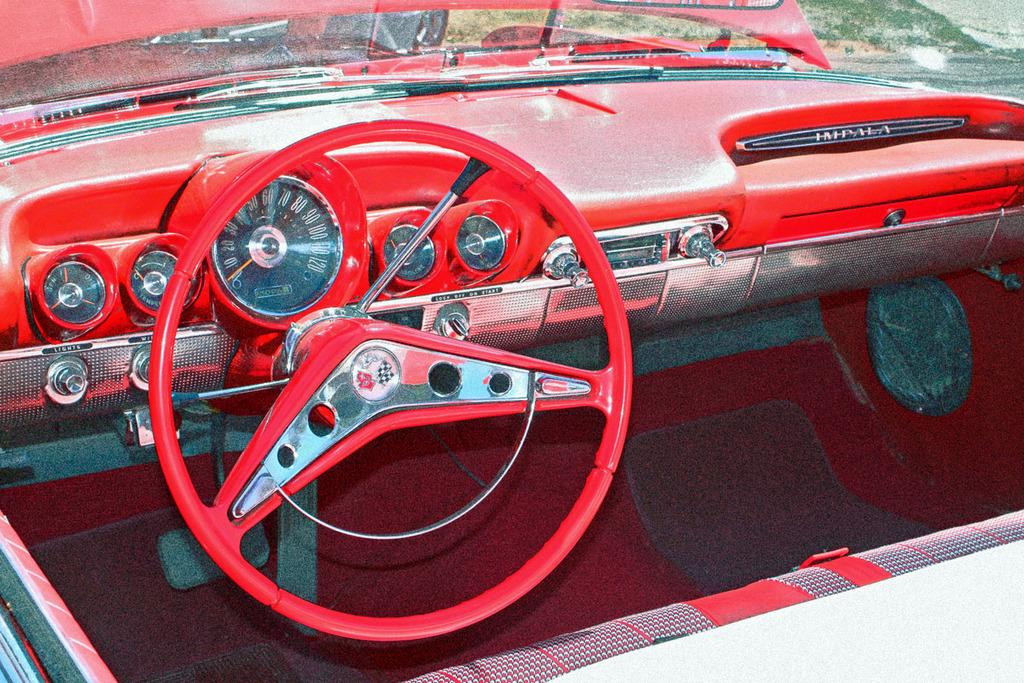What is the primary object in the image? There is a steering wheel in the image. What other instrument related to driving can be seen in the image? There is a speedometer in the image. Are there any other instruments related to the vehicle's performance in the image? Yes, there are meter gauges in the image. What can be seen in the background of the image? There is grass visible in the background of the image. What type of pot is placed on the button in the image? There is no pot or button present in the image. 